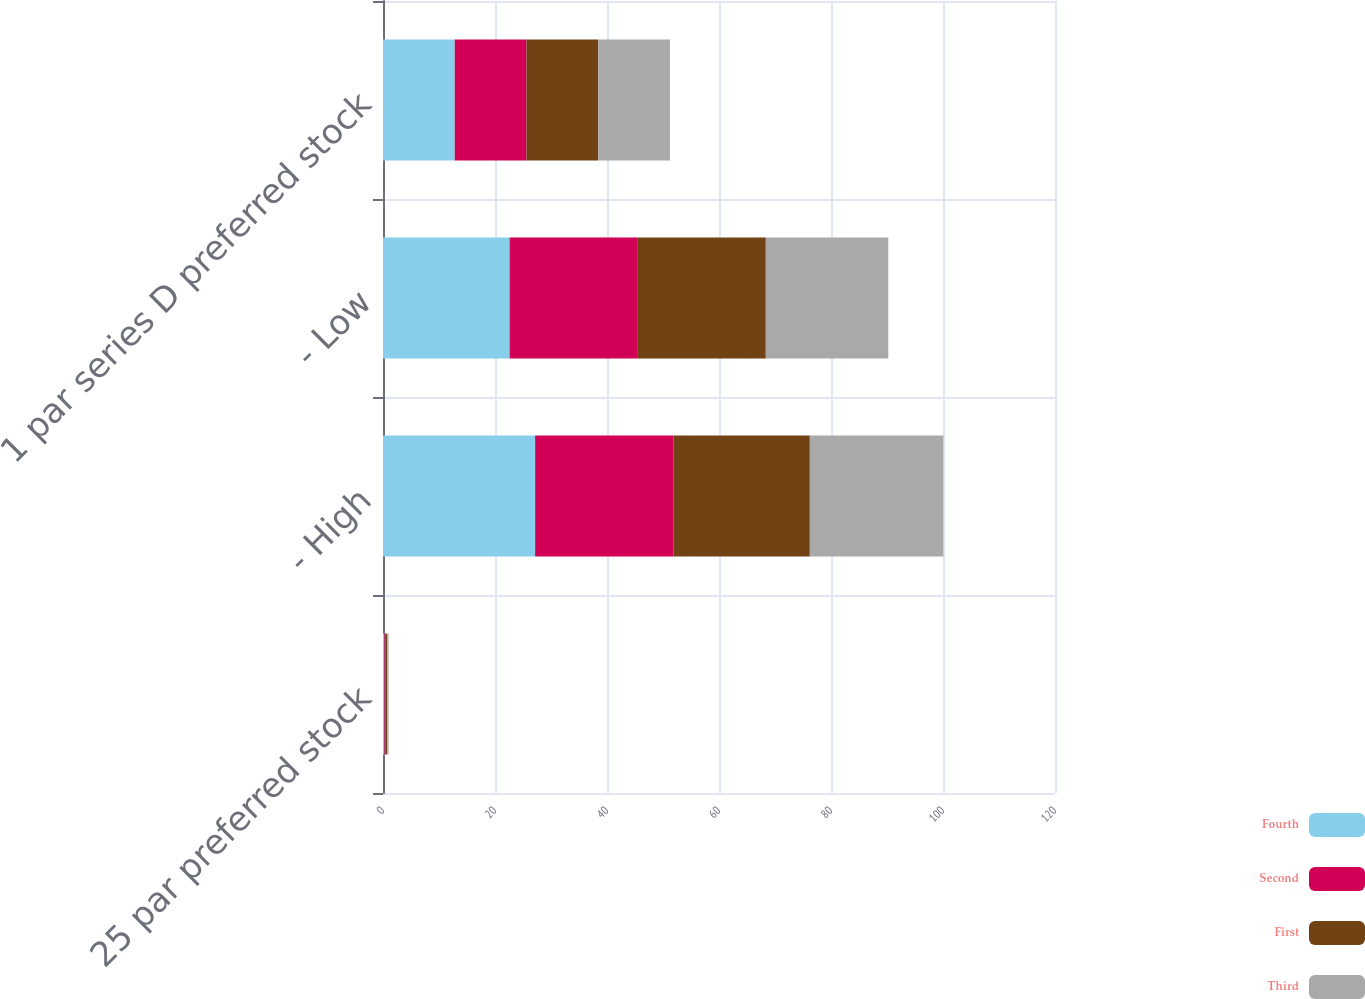Convert chart. <chart><loc_0><loc_0><loc_500><loc_500><stacked_bar_chart><ecel><fcel>25 par preferred stock<fcel>- High<fcel>- Low<fcel>1 par series D preferred stock<nl><fcel>Fourth<fcel>0.25<fcel>27.17<fcel>22.61<fcel>12.81<nl><fcel>Second<fcel>0.25<fcel>24.74<fcel>22.9<fcel>12.81<nl><fcel>First<fcel>0.25<fcel>24.31<fcel>22.85<fcel>12.81<nl><fcel>Third<fcel>0.25<fcel>23.85<fcel>21.87<fcel>12.81<nl></chart> 